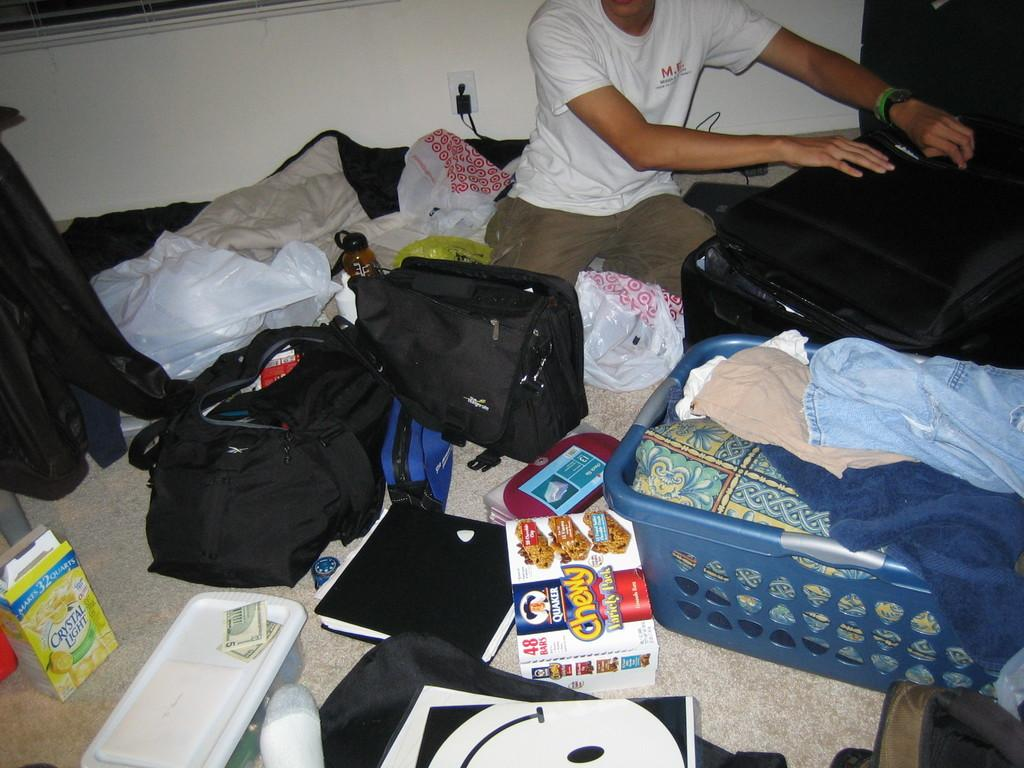What is the person in the image doing? The person is sitting in the image. What is the person holding? The person is holding a suitcase. What can be seen on the floor in the image? There are bags, books, and other objects on the floor. What type of riddle can be solved by the flock of steam in the image? There is no riddle, flock, or steam present in the image. 